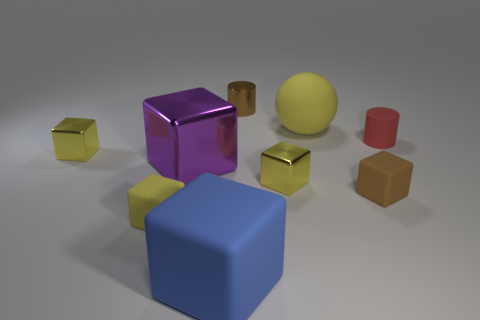Subtract all brown spheres. How many yellow cubes are left? 3 Subtract all purple blocks. How many blocks are left? 5 Subtract all blue rubber blocks. How many blocks are left? 5 Subtract 1 blocks. How many blocks are left? 5 Subtract all red cubes. Subtract all red cylinders. How many cubes are left? 6 Subtract all blocks. How many objects are left? 3 Subtract all purple matte things. Subtract all brown blocks. How many objects are left? 8 Add 5 red cylinders. How many red cylinders are left? 6 Add 9 tiny purple things. How many tiny purple things exist? 9 Subtract 2 yellow blocks. How many objects are left? 7 